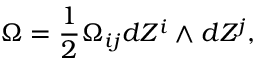Convert formula to latex. <formula><loc_0><loc_0><loc_500><loc_500>\Omega = \frac { 1 } { 2 } \Omega _ { i j } d Z ^ { i } \wedge d Z ^ { j } ,</formula> 